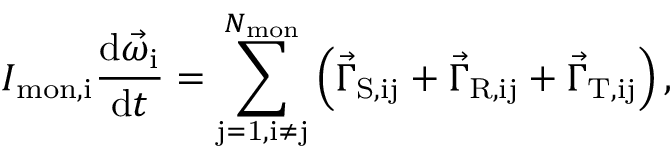<formula> <loc_0><loc_0><loc_500><loc_500>I _ { m o n , i } \frac { d \vec { \omega } _ { i } } { d t } = \sum _ { j = 1 , i \neq j } ^ { N _ { m o n } } { \left ( \vec { \Gamma } _ { S , i j } + \vec { \Gamma } _ { R , i j } + \vec { \Gamma } _ { T , i j } \right ) } \, ,</formula> 